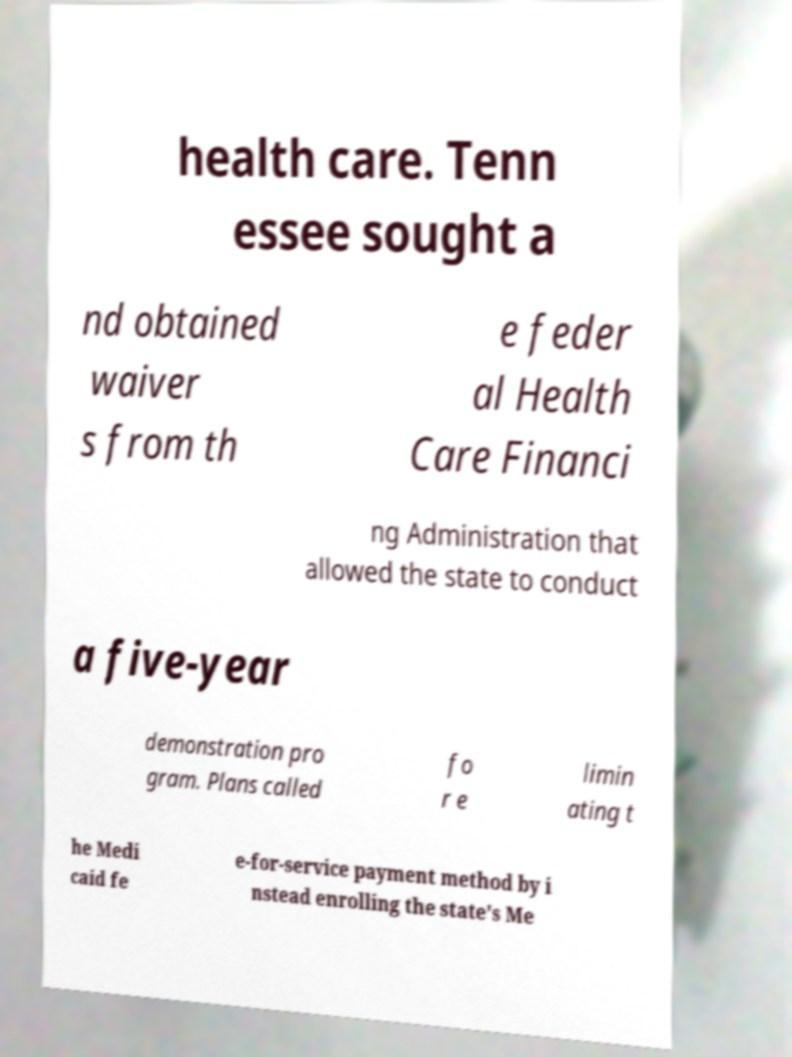I need the written content from this picture converted into text. Can you do that? health care. Tenn essee sought a nd obtained waiver s from th e feder al Health Care Financi ng Administration that allowed the state to conduct a five-year demonstration pro gram. Plans called fo r e limin ating t he Medi caid fe e-for-service payment method by i nstead enrolling the state's Me 